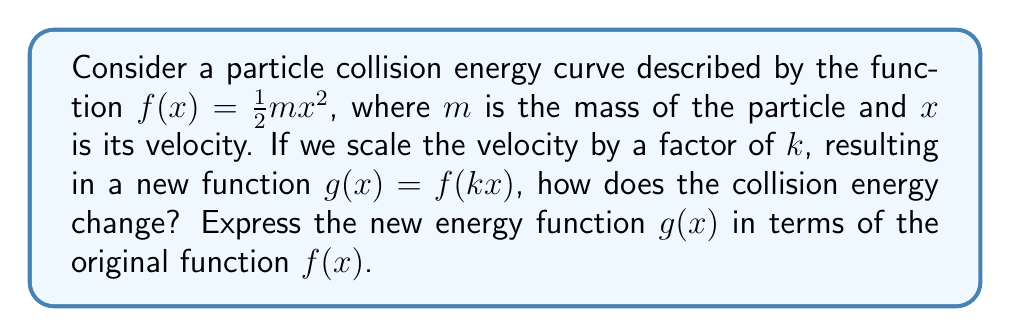Can you answer this question? Let's approach this step-by-step:

1) The original function is $f(x) = \frac{1}{2}mx^2$.

2) We're applying a horizontal scaling transformation by a factor of $k$. This means we replace every $x$ in the original function with $kx$.

3) Let's substitute $kx$ for $x$ in the original function:

   $g(x) = f(kx) = \frac{1}{2}m(kx)^2$

4) Let's expand this:

   $g(x) = \frac{1}{2}m(k^2x^2)$

5) Rearranging the terms:

   $g(x) = (\frac{1}{2}mk^2)x^2$

6) Now, let's compare this to the original function $f(x) = \frac{1}{2}mx^2$

7) We can see that $g(x) = k^2 \cdot (\frac{1}{2}mx^2) = k^2f(x)$

This means that scaling the velocity by a factor of $k$ results in scaling the entire energy function by a factor of $k^2$.
Answer: $g(x) = k^2f(x)$ 